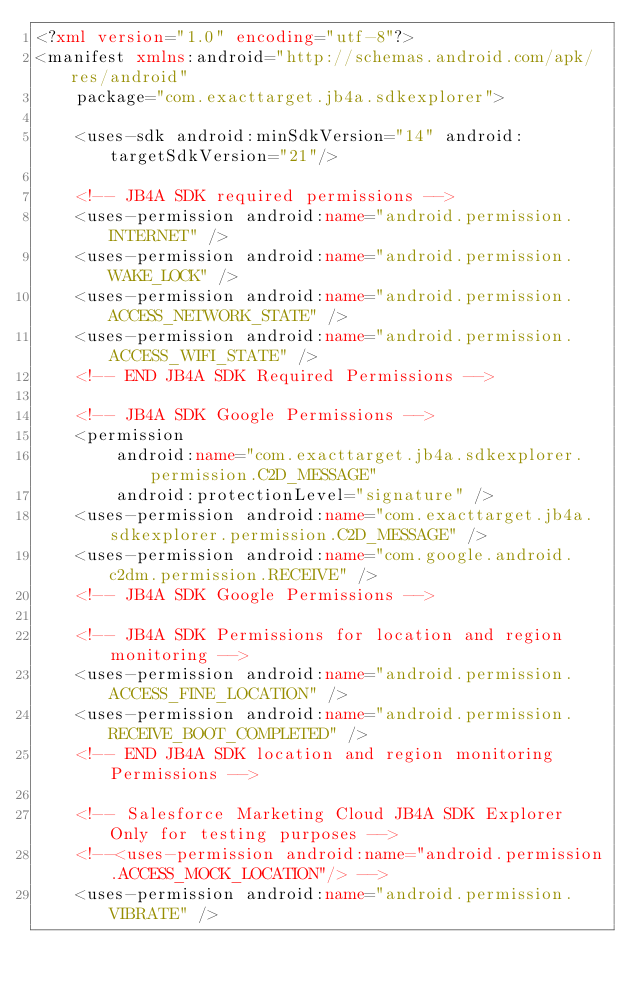Convert code to text. <code><loc_0><loc_0><loc_500><loc_500><_XML_><?xml version="1.0" encoding="utf-8"?>
<manifest xmlns:android="http://schemas.android.com/apk/res/android"
    package="com.exacttarget.jb4a.sdkexplorer">

    <uses-sdk android:minSdkVersion="14" android:targetSdkVersion="21"/>

    <!-- JB4A SDK required permissions -->
    <uses-permission android:name="android.permission.INTERNET" />
    <uses-permission android:name="android.permission.WAKE_LOCK" />
    <uses-permission android:name="android.permission.ACCESS_NETWORK_STATE" />
    <uses-permission android:name="android.permission.ACCESS_WIFI_STATE" />
    <!-- END JB4A SDK Required Permissions -->

    <!-- JB4A SDK Google Permissions -->
    <permission
        android:name="com.exacttarget.jb4a.sdkexplorer.permission.C2D_MESSAGE"
        android:protectionLevel="signature" />
    <uses-permission android:name="com.exacttarget.jb4a.sdkexplorer.permission.C2D_MESSAGE" />
    <uses-permission android:name="com.google.android.c2dm.permission.RECEIVE" />
    <!-- JB4A SDK Google Permissions -->

    <!-- JB4A SDK Permissions for location and region monitoring -->
    <uses-permission android:name="android.permission.ACCESS_FINE_LOCATION" />
    <uses-permission android:name="android.permission.RECEIVE_BOOT_COMPLETED" />
    <!-- END JB4A SDK location and region monitoring Permissions -->

    <!-- Salesforce Marketing Cloud JB4A SDK Explorer Only for testing purposes -->
    <!--<uses-permission android:name="android.permission.ACCESS_MOCK_LOCATION"/> --> 
    <uses-permission android:name="android.permission.VIBRATE" /></code> 